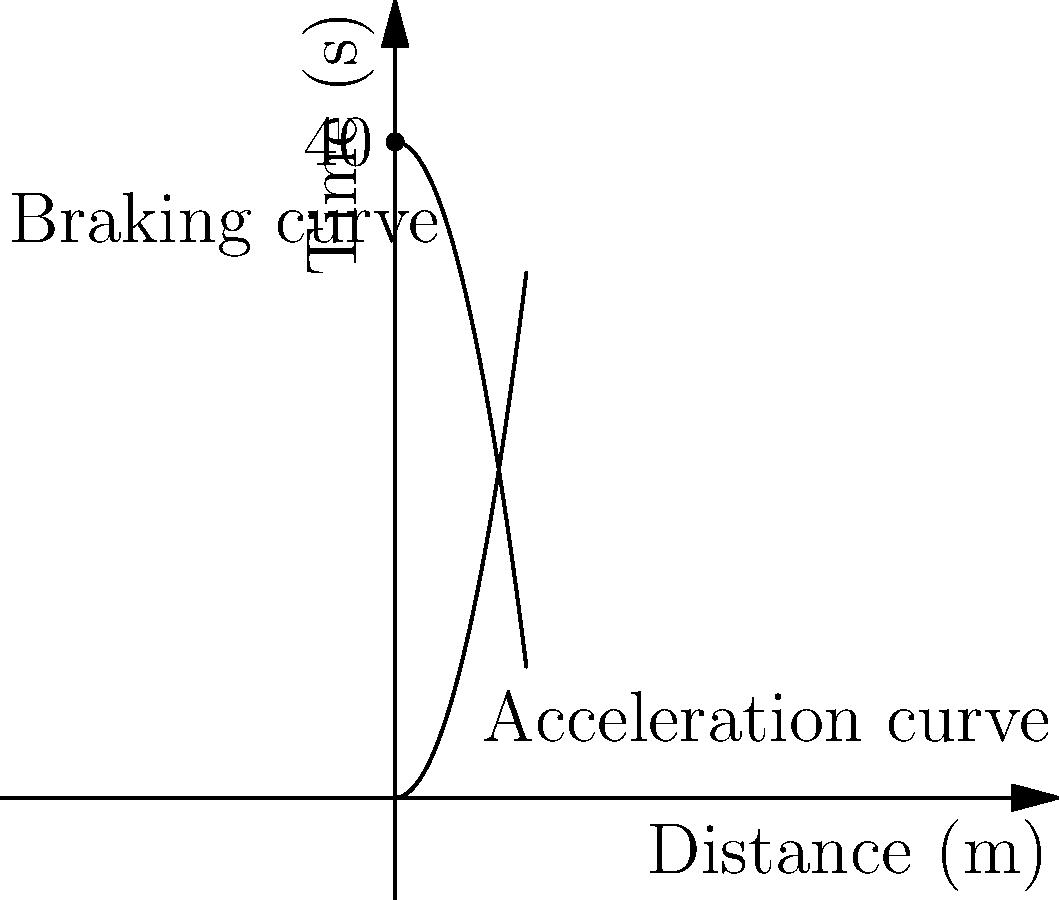As a concerned father who just bought a new car, you want to ensure safe following distances. The graph shows the acceleration and braking curves for your new car. The vertical axis represents time in seconds, and the horizontal axis represents distance in meters. The car can accelerate from 0 to 40 meters in 8 seconds, and it can brake from 40 meters to 0 in 8 seconds. What is the minimum safe following distance in meters if you're traveling at a speed that would cover 40 meters in 4 seconds? Let's approach this step-by-step:

1) First, we need to understand what the graph represents:
   - The lower curve shows acceleration from 0 to 40 meters in 8 seconds.
   - The upper curve shows braking from 40 meters to 0 in 8 seconds.

2) We're told that we're traveling at a speed that covers 40 meters in 4 seconds. This is our current speed.

3) The safe following distance should be at least the distance it takes to stop the car completely from this speed.

4) To find this, we need to look at the braking curve (the upper curve).

5) At 4 seconds on the time axis, we can see that the braking curve intersects at about 30 meters on the distance axis.

6) This means that if we start braking at 4 seconds, we'll still travel about 30 meters before coming to a complete stop.

7) Therefore, the minimum safe following distance should be 30 meters.

8) However, it's always wise to add a safety margin. A common rule is the "3-second rule", which would add an additional 30 meters (since we're covering 40 meters in 4 seconds, in 3 seconds we'd cover 30 meters).

9) So, a safer following distance would be 30 + 30 = 60 meters.
Answer: 60 meters 